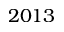<formula> <loc_0><loc_0><loc_500><loc_500>2 0 1 3</formula> 